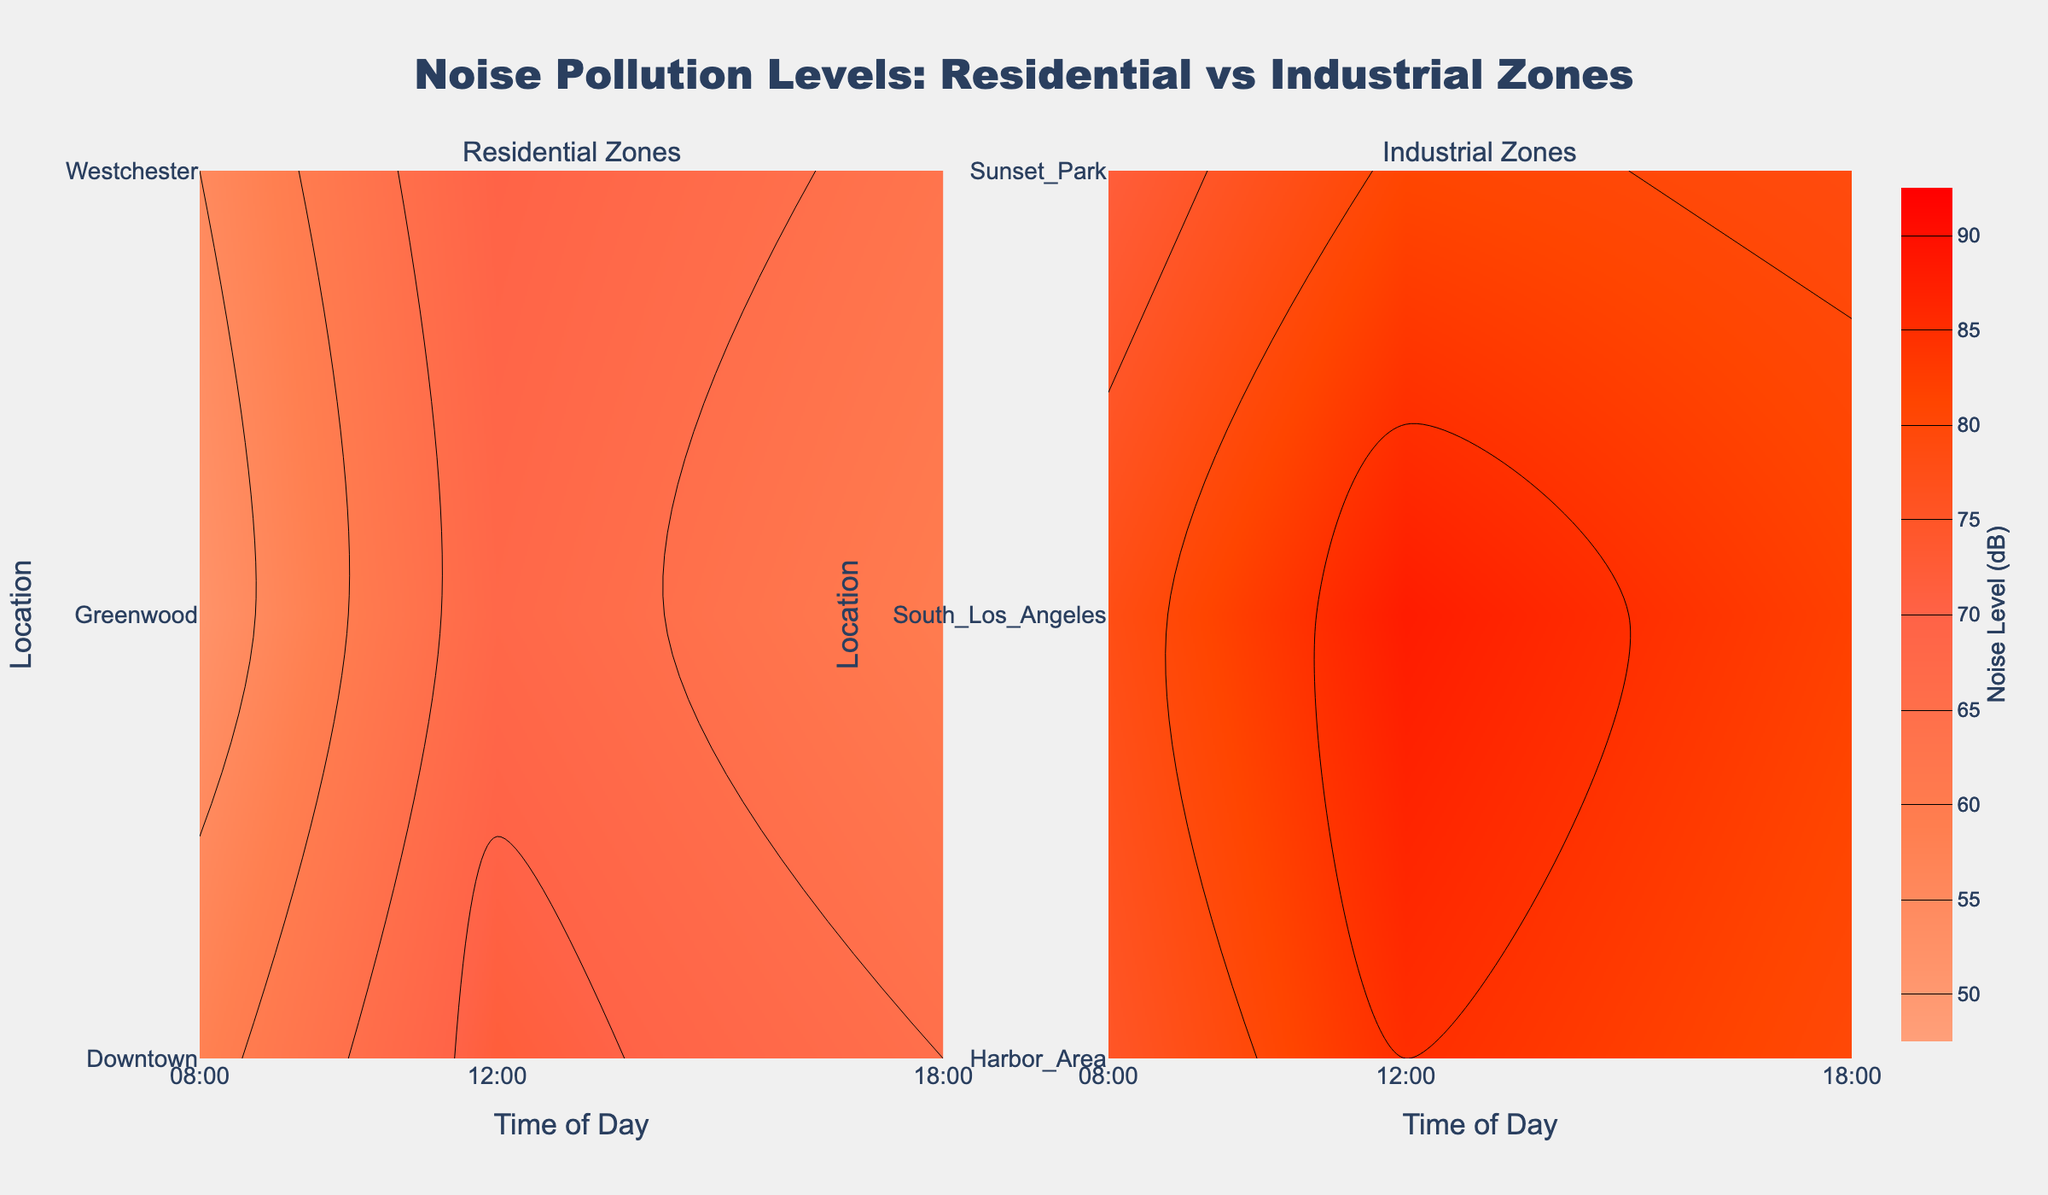What is the title of the figure? The title is usually displayed prominently at the top. Here, it reads "Noise Pollution Levels: Residential vs Industrial Zones".
Answer: Noise Pollution Levels: Residential vs Industrial Zones At what time do Industrial zones experience the highest noise level? By examining the Industrial Zones subplot, we see the highest contour values occurring around 12:00 PM.
Answer: 12:00 PM Which residential location has the highest noise level at 12:00 PM? Looking at the Residential Zones subplot and checking the 12:00 PM time slice, Downtown has the highest contour values indicating the highest noise levels.
Answer: Downtown How does the noise level in Greenwood at 08:00 AM compare to that in Sunset Park at the same time? In the Residential Zones subplot, Greenwood's contour value at 08:00 AM is lower compared to the corresponding value in Sunset Park in the Industrial Zones subplot.
Answer: Lower What is the average noise level in Westchester across the three measured times? The noise levels in Westchester at 08:00, 12:00, and 18:00 are 55, 70, and 63 dB respectively. Add these values and divide by 3 to find the average: (55 + 70 + 63) / 3 = 62.67 dB.
Answer: 62.67 dB Which location in residential zones has the least variation in noise levels throughout the day? By comparing the spread of contour levels for each residential location throughout the day, Greenwood has the least variation, showing more uniform levels across 08:00, 12:00, and 18:00.
Answer: Greenwood What is the range of the noise levels in the Industrial zones at 18:00 PM? In the Industrial Zones subplot, the noise levels at 18:00 PM for Harbor Area, South Los Angeles, and Sunset Park are 80, 82, and 79 dB respectively. The range is the difference between the maximum and minimum values: 82 - 79 = 3 dB.
Answer: 3 dB How do the noise levels change throughout the day in Downtown? Observing the Residential Zones subplot, Downtown's noise levels increase from 58 dB at 08:00, peak at 72 dB at 12:00, and then decrease to 65 dB at 18:00.
Answer: Increase, then decrease Comparing the overall noise levels, do residential zones or industrial zones experience higher average noise levels? By looking at the general contour levels, Industrial Zones exhibit higher noise levels uniformly across all times and locations compared to the Residential Zones.
Answer: Industrial Zones Which time of day generally shows the highest noise levels across both zones? Both subplots indicate peak noise levels at 12:00 PM for their respective zones.
Answer: 12:00 PM 